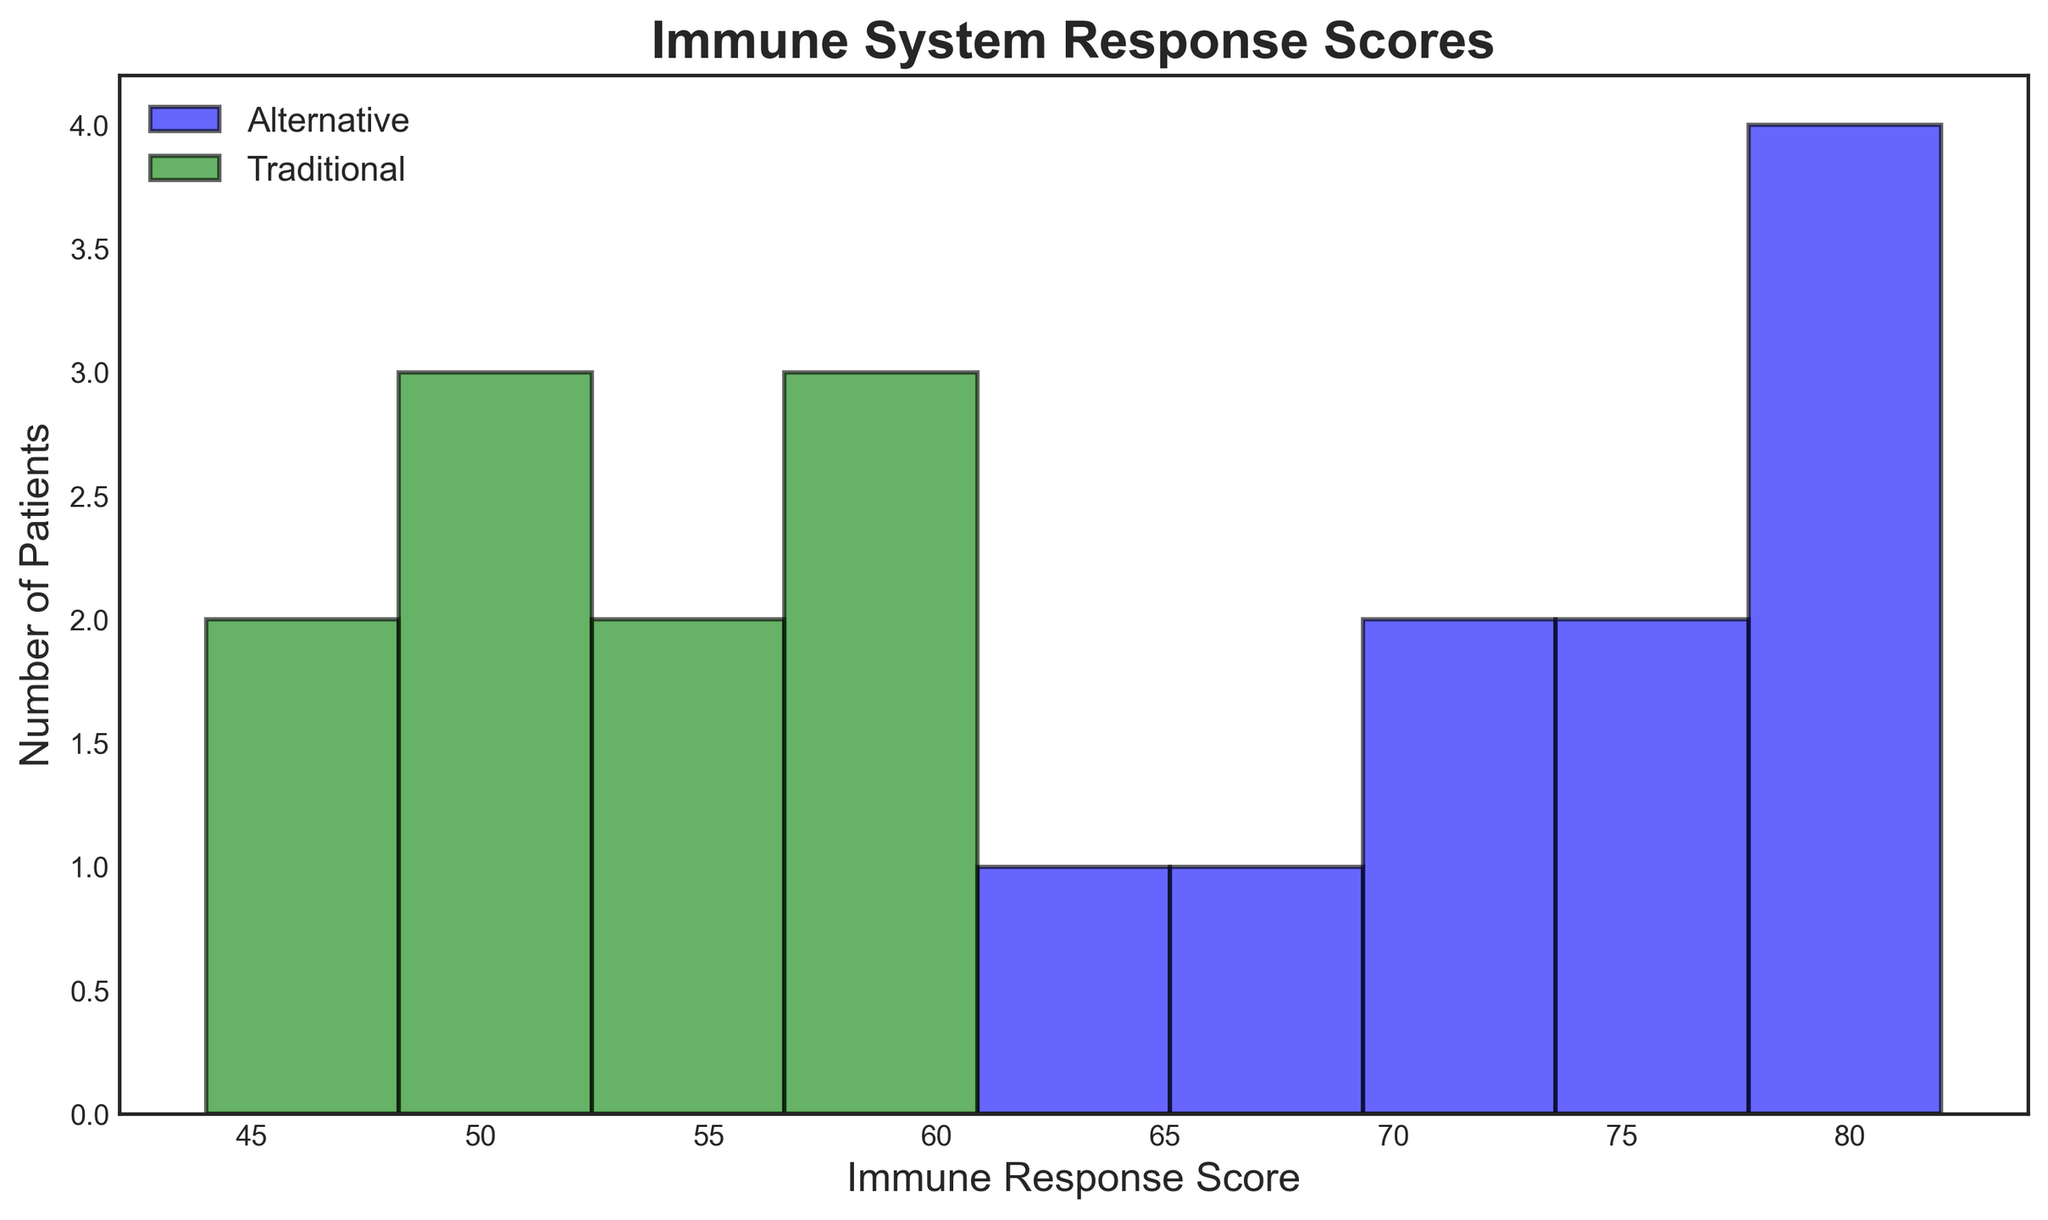What is the average Immune Response Score for patients using alternative treatments? To find the average score for patients using alternative treatments, sum all the scores for the Alternative treatment group and then divide by the number of Alternative patients. Scores: [75, 80, 70, 65, 78, 82, 67, 72, 76, 81]. Sum = 736. Number of patients = 10. So, the average is 736 / 10 = 73.6
Answer: 73.6 Which treatment group has a higher peak in their histogram? The peak in a histogram represents the bin (range of scores) with the highest frequency (tallest bar). By comparing the histograms, we can observe that the alternative treatments group has a higher peak.
Answer: Alternative How many bins are used in the histogram? The histogram is divided into intervals or bins. You can count these intervals to determine the number of bins. By counting the evenly spaced segments on the x-axis, we see there are 9 bins.
Answer: 9 What is the range of Immune Response Scores for the Traditional treatment group? The range of scores for the Traditional treatment group can be determined by finding the minimum and maximum scores in the group. The minimum score is 44 and the maximum score is 60. Therefore, the range is 60 - 44 = 16.
Answer: 16 Compare the centers of the distributions for the two treatment groups. Which appears to be higher? By observing the approximate central value, or mode, around which the majority of values are clustered, the distribution of the Alternative treatment group is centered around a higher Immune Response Score compared to the Traditional group.
Answer: Alternative Between the two treatment groups, which has the largest number of patients with their Immune Response Score in the highest bin? By analyzing the highest bin range from the histogram and counting the frequency of patients, we can see that the Alternative group has more patients in the highest bin range (81-85) compared to the Traditional group.
Answer: Alternative What is the tallest bar's value for the Alternative treatment group? Identifying the tallest bar in the histogram for the Alternative treatment group, we refer to the height of this bar which indicates the number of patients. This tallest bar represents **3 patients**.
Answer: 3 What is the difference in the number of patients between the highest bins of Traditional and Alternative treatment groups? Counting the number of patients in the highest bin (81-85) for each group: Alternative has 2, and Traditional has 0. Therefore, the difference is 2 - 0 = 2.
Answer: 2 What's the average Immune Response Score for the Traditional treatment group? To find the average score for the Traditional treatment group, sum all the scores for the Traditional treatment group and then divide by the number of Traditional patients. Scores: [50, 45, 55, 60, 52, 49, 58, 57, 44, 53]. Sum = 523. Number of patients = 10. So, the average is 523 / 10 = 52.3
Answer: 52.3 In terms of frequency distribution, which treatment type shows more diversity in Immune Response Scores? Diversity can be inferred from the spread of scores. The Traditional group has a wider spread of lower scores spread across multiple bins (44-60), indicating more diversity compared to the Alternative group, which is more concentrated in higher bins.
Answer: Traditional 